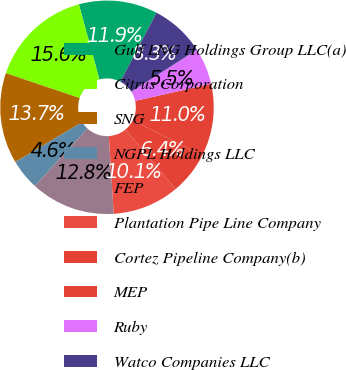Convert chart to OTSL. <chart><loc_0><loc_0><loc_500><loc_500><pie_chart><fcel>Gulf LNG Holdings Group LLC(a)<fcel>Citrus Corporation<fcel>SNG<fcel>NGPL Holdings LLC<fcel>FEP<fcel>Plantation Pipe Line Company<fcel>Cortez Pipeline Company(b)<fcel>MEP<fcel>Ruby<fcel>Watco Companies LLC<nl><fcel>11.92%<fcel>15.58%<fcel>13.75%<fcel>4.61%<fcel>12.83%<fcel>10.09%<fcel>6.44%<fcel>11.01%<fcel>5.52%<fcel>8.26%<nl></chart> 